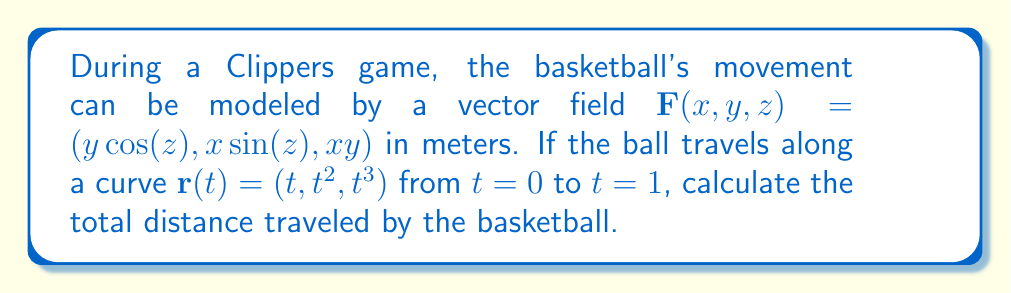Provide a solution to this math problem. To find the total distance traveled by the basketball, we need to compute the line integral of the vector field along the given curve. Let's follow these steps:

1) First, we need to parameterize the curve:
   $\mathbf{r}(t) = (t, t^2, t^3)$ for $0 \leq t \leq 1$

2) Next, we calculate $\frac{d\mathbf{r}}{dt}$:
   $\frac{d\mathbf{r}}{dt} = (1, 2t, 3t^2)$

3) Now, we evaluate $\mathbf{F}(\mathbf{r}(t))$:
   $\mathbf{F}(\mathbf{r}(t)) = (t^2\cos(t^3), t\sin(t^3), t^3)$

4) The line integral is given by:
   $$\int_C \mathbf{F} \cdot d\mathbf{r} = \int_0^1 \mathbf{F}(\mathbf{r}(t)) \cdot \frac{d\mathbf{r}}{dt} dt$$

5) Let's compute the dot product inside the integral:
   $\mathbf{F}(\mathbf{r}(t)) \cdot \frac{d\mathbf{r}}{dt} = t^2\cos(t^3) \cdot 1 + t\sin(t^3) \cdot 2t + t^3 \cdot 3t^2$
   $= t^2\cos(t^3) + 2t^2\sin(t^3) + 3t^5$

6) Now our integral becomes:
   $$\int_0^1 (t^2\cos(t^3) + 2t^2\sin(t^3) + 3t^5) dt$$

7) This integral doesn't have a simple antiderivative, so we'll use numerical integration. Using a computer algebra system or numerical integration tool, we find:
   $$\int_0^1 (t^2\cos(t^3) + 2t^2\sin(t^3) + 3t^5) dt \approx 0.7166$$

Therefore, the total distance traveled by the basketball is approximately 0.7166 meters.
Answer: $0.7166$ meters 